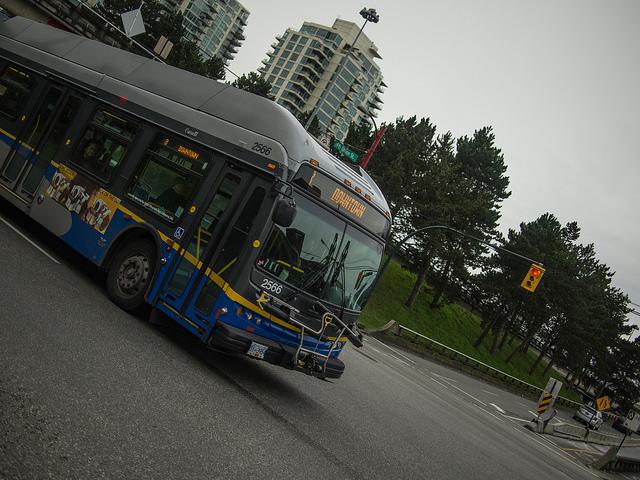How many of this objects wheels are touching the ground?
Short answer required. 1. What type of day is it?
Answer briefly. Cloudy. What color is the traffic light?
Keep it brief. Red. Are the trees naked of leaves?
Concise answer only. No. The 3 stripes on the bus are yellow, white, and what?
Keep it brief. Blue. What city is this in?
Short answer required. Seattle. Is the weather nice today?
Write a very short answer. No. Why is the bus moving?
Short answer required. Because it has to go. What is the number of the bus?
Short answer required. 2566. How many buses?
Write a very short answer. 1. 